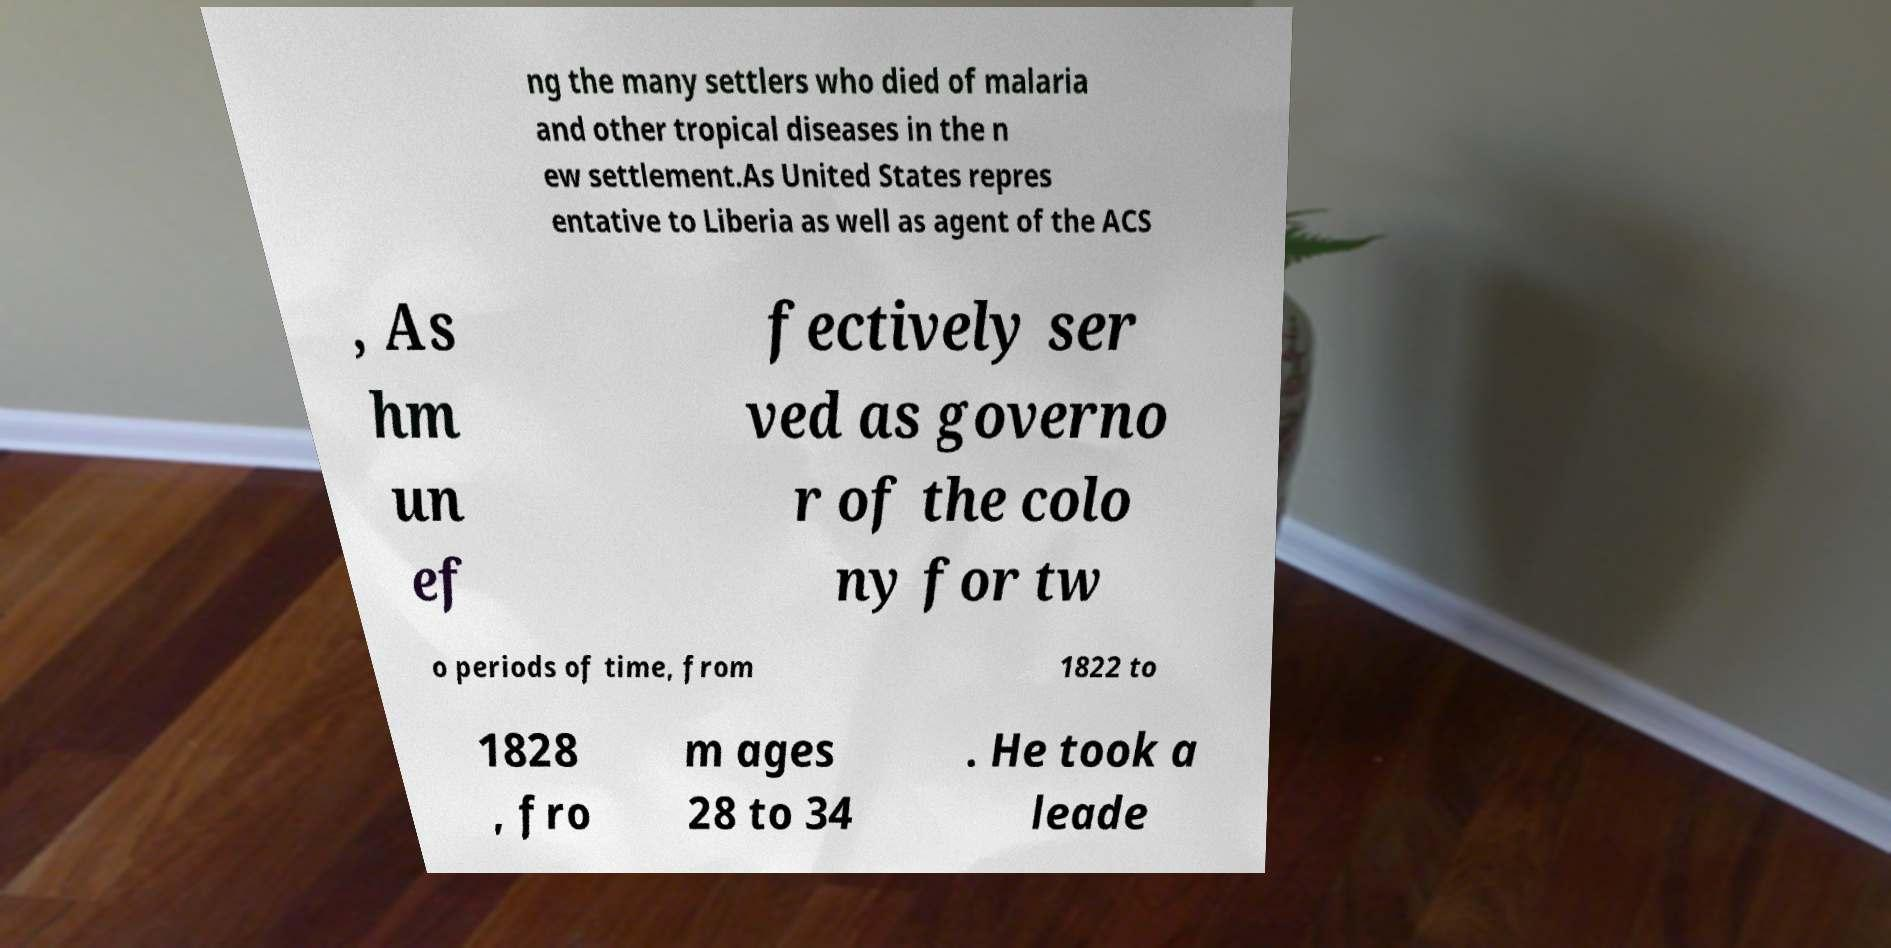For documentation purposes, I need the text within this image transcribed. Could you provide that? ng the many settlers who died of malaria and other tropical diseases in the n ew settlement.As United States repres entative to Liberia as well as agent of the ACS , As hm un ef fectively ser ved as governo r of the colo ny for tw o periods of time, from 1822 to 1828 , fro m ages 28 to 34 . He took a leade 